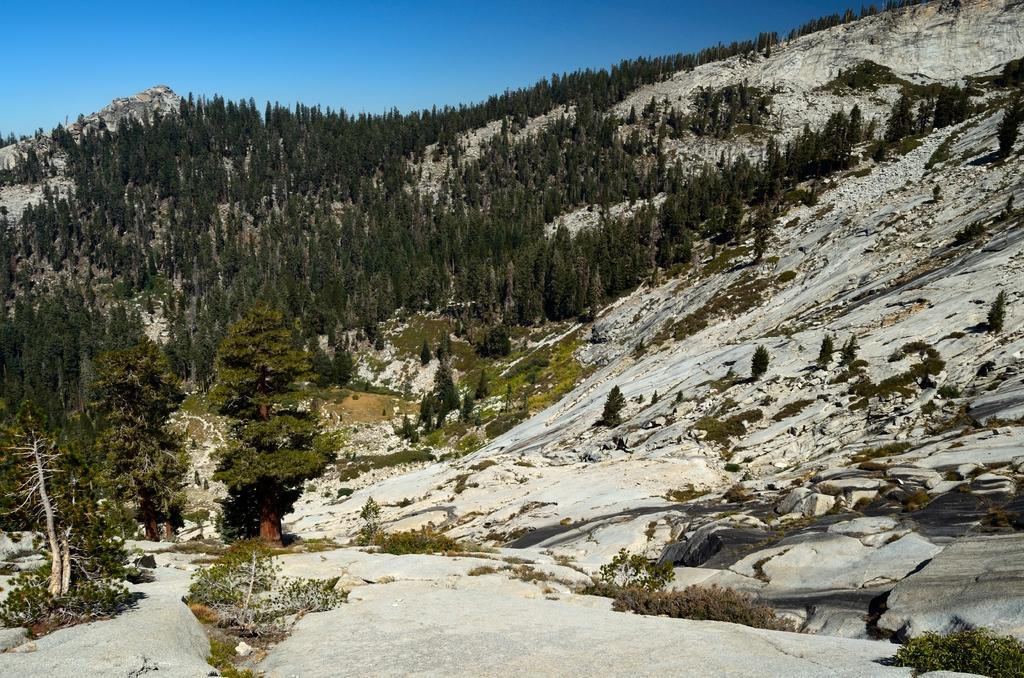What type of natural features can be seen in the image? There are trees and rocky mountains in the image. Can you describe the trees in the image? The facts provided do not give specific details about the trees, but they are present in the image. What type of terrain is depicted by the rocky mountains? The rocky mountains suggest a rugged and mountainous landscape. Where is the shop located in the image? There is no shop present in the image; it features trees and rocky mountains. How many legs can be seen on the trees in the image? Trees do not have legs, so this question cannot be answered based on the image. 